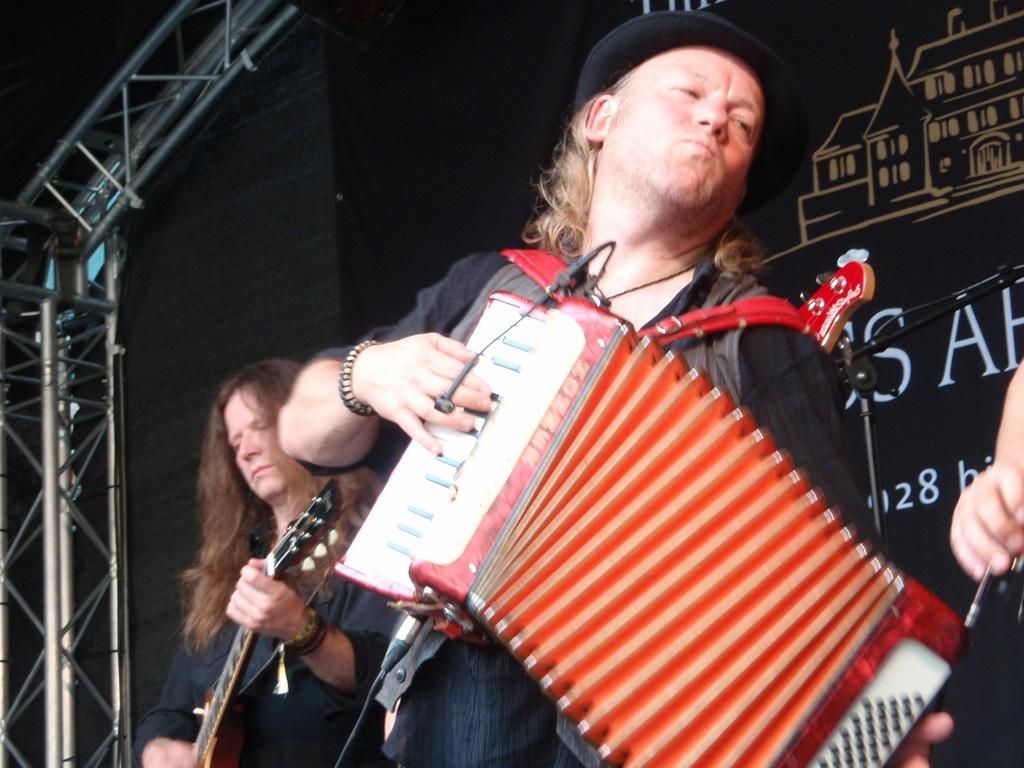How many people are in the image? There are three persons in the image. What are the persons doing in the image? The persons are playing musical instruments. What can be seen in the background of the image? There is a wall and metal rods in the background of the image. Can you describe the setting where the image might have been taken? The image may have been taken on a stage. What type of eggnog is being served to the audience in the image? There is no eggnog or audience present in the image; it features three persons playing musical instruments. Can you tell me how many answers the persons are providing in the image? There is no indication in the image that the persons are providing answers, as they are playing musical instruments. 